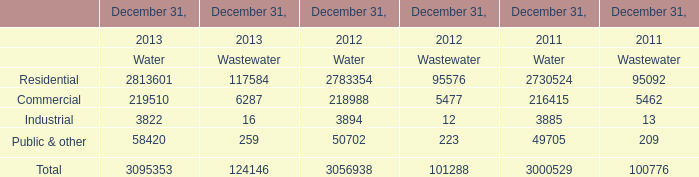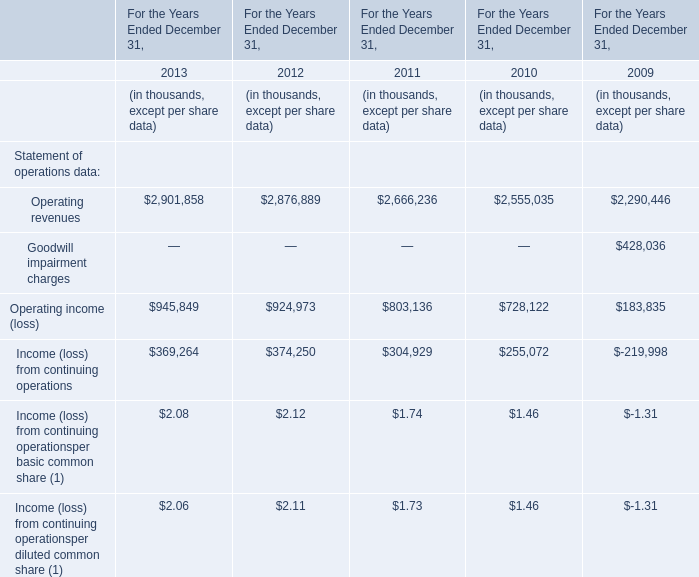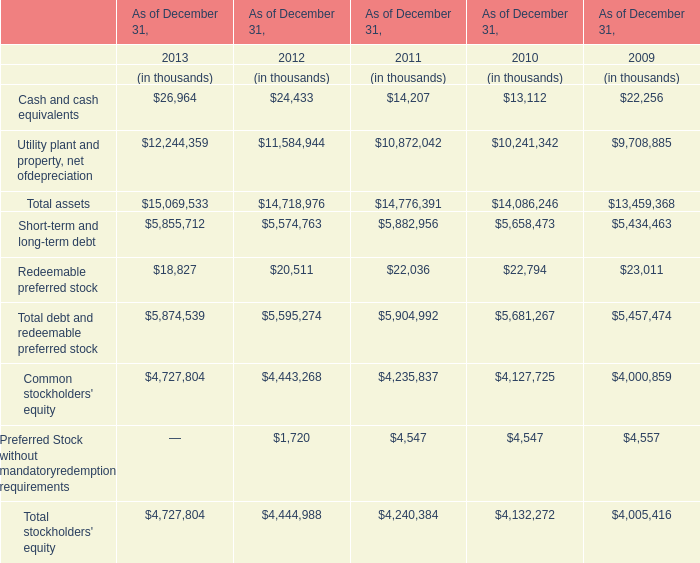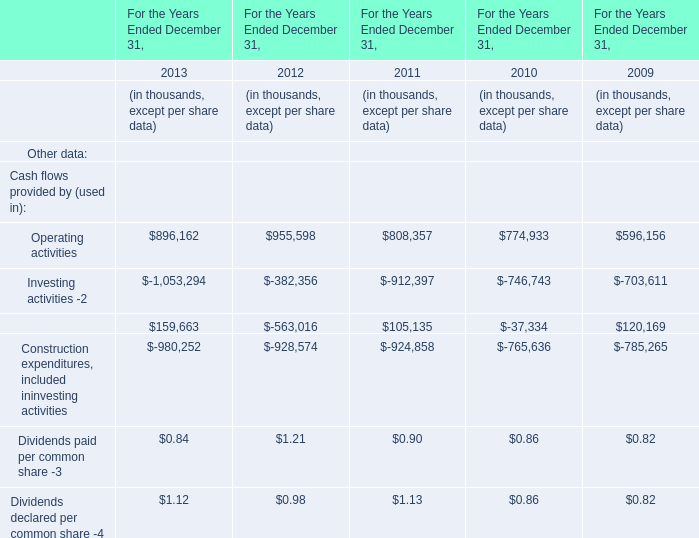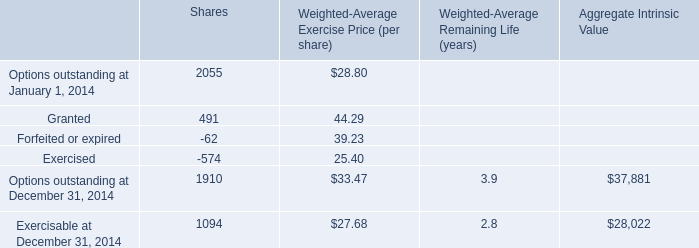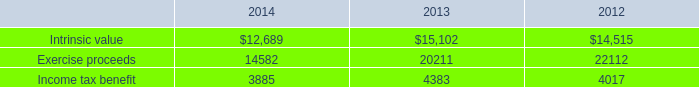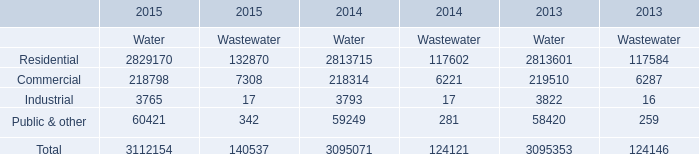In the year with largest amount of Operating revenues in table 1, what's the increasing rate of Operating income (loss) in table 1? 
Computations: ((945849 - 924973) / 924973)
Answer: 0.02257. 